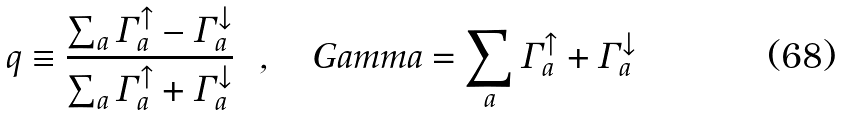<formula> <loc_0><loc_0><loc_500><loc_500>q \equiv \frac { \sum _ { a } \Gamma ^ { \uparrow } _ { a } - \Gamma ^ { \downarrow } _ { a } } { \sum _ { a } \Gamma ^ { \uparrow } _ { a } + \Gamma ^ { \downarrow } _ { a } } \ \ , \quad G a m m a = \sum _ { a } \Gamma ^ { \uparrow } _ { a } + \Gamma ^ { \downarrow } _ { a }</formula> 